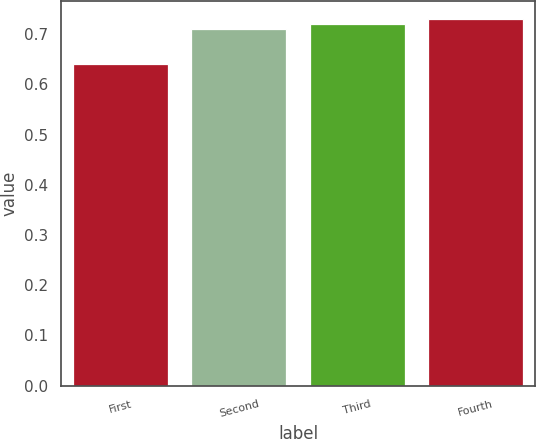<chart> <loc_0><loc_0><loc_500><loc_500><bar_chart><fcel>First<fcel>Second<fcel>Third<fcel>Fourth<nl><fcel>0.64<fcel>0.71<fcel>0.72<fcel>0.73<nl></chart> 